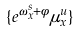<formula> <loc_0><loc_0><loc_500><loc_500>\{ e ^ { \omega _ { x } ^ { s } + \phi } \mu ^ { u } _ { x } \}</formula> 